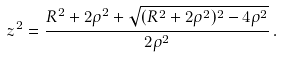<formula> <loc_0><loc_0><loc_500><loc_500>z ^ { 2 } = \frac { R ^ { 2 } + 2 \rho ^ { 2 } + \sqrt { ( R ^ { 2 } + 2 \rho ^ { 2 } ) ^ { 2 } - 4 \rho ^ { 2 } } } { 2 \rho ^ { 2 } } \, .</formula> 